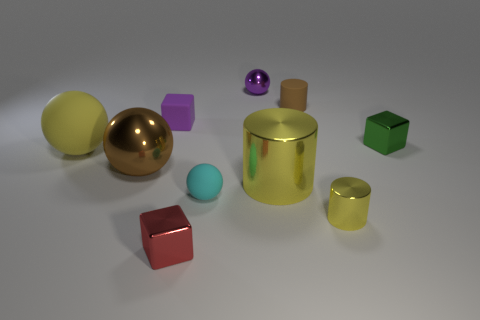Subtract all green cubes. Subtract all gray cylinders. How many cubes are left? 2 Subtract all balls. How many objects are left? 6 Subtract all small balls. Subtract all tiny metallic blocks. How many objects are left? 6 Add 6 big yellow spheres. How many big yellow spheres are left? 7 Add 1 big gray cylinders. How many big gray cylinders exist? 1 Subtract 0 cyan blocks. How many objects are left? 10 